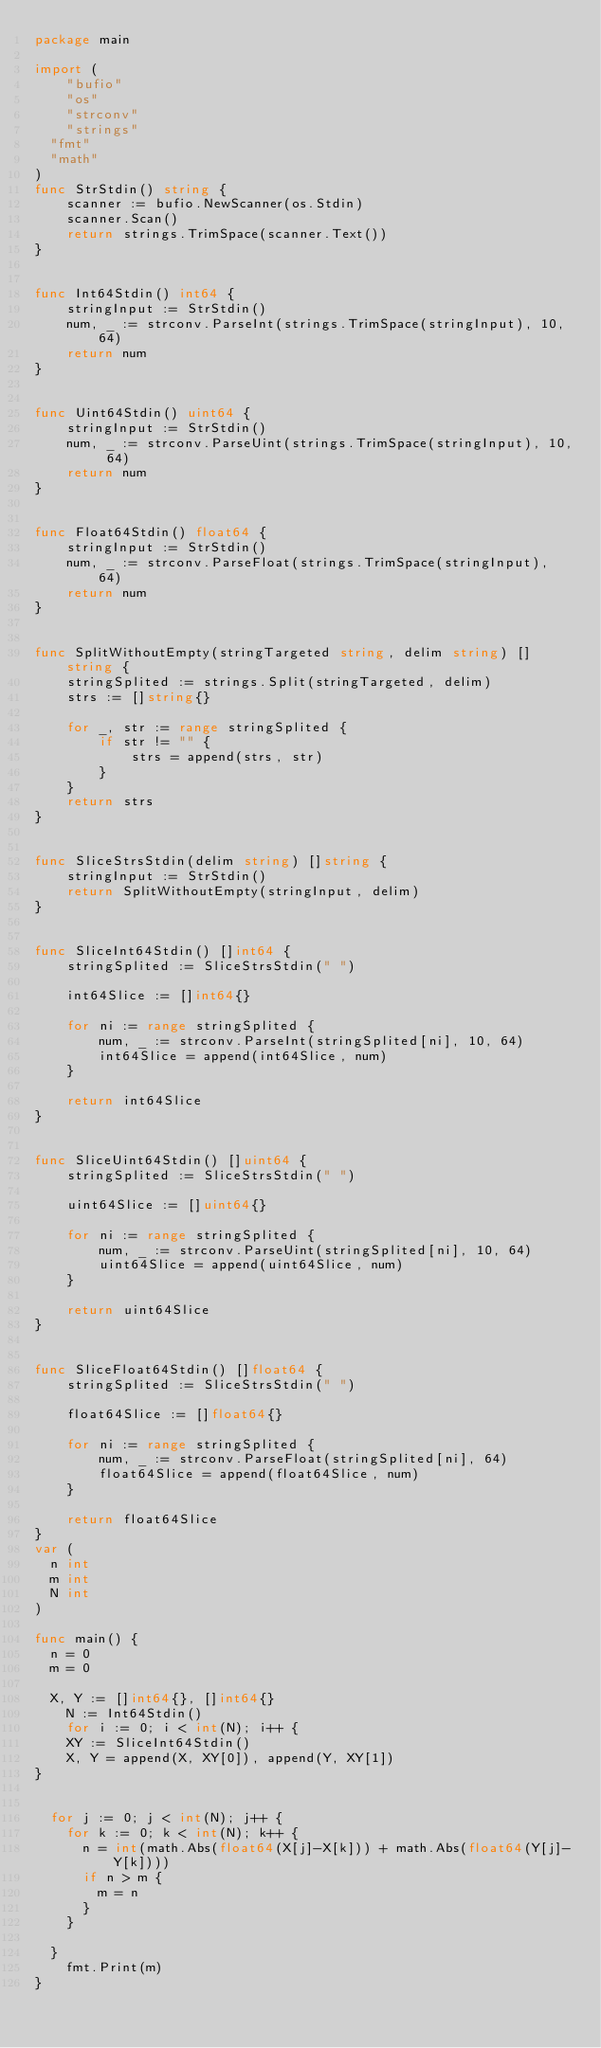<code> <loc_0><loc_0><loc_500><loc_500><_Go_>package main

import (
    "bufio"  
    "os"  
    "strconv"  
    "strings"
	"fmt"
	"math"
)
func StrStdin() string {  
    scanner := bufio.NewScanner(os.Stdin)  
    scanner.Scan()  
    return strings.TrimSpace(scanner.Text())  
}  


func Int64Stdin() int64 {  
    stringInput := StrStdin()  
    num, _ := strconv.ParseInt(strings.TrimSpace(stringInput), 10, 64)  
    return num  
}  


func Uint64Stdin() uint64 {  
    stringInput := StrStdin()  
    num, _ := strconv.ParseUint(strings.TrimSpace(stringInput), 10, 64)  
    return num  
}  


func Float64Stdin() float64 {  
    stringInput := StrStdin()  
    num, _ := strconv.ParseFloat(strings.TrimSpace(stringInput), 64)  
    return num  
}  


func SplitWithoutEmpty(stringTargeted string, delim string) []string {  
    stringSplited := strings.Split(stringTargeted, delim)  
    strs := []string{}  

    for _, str := range stringSplited {  
        if str != "" {  
            strs = append(strs, str)  
        }  
    }  
    return strs  
}  


func SliceStrsStdin(delim string) []string {  
    stringInput := StrStdin()  
    return SplitWithoutEmpty(stringInput, delim)  
}  


func SliceInt64Stdin() []int64 {  
    stringSplited := SliceStrsStdin(" ")  

    int64Slice := []int64{}  

    for ni := range stringSplited {  
        num, _ := strconv.ParseInt(stringSplited[ni], 10, 64)  
        int64Slice = append(int64Slice, num)  
    }  

    return int64Slice  
}  


func SliceUint64Stdin() []uint64 {  
    stringSplited := SliceStrsStdin(" ")  

    uint64Slice := []uint64{}  

    for ni := range stringSplited {  
        num, _ := strconv.ParseUint(stringSplited[ni], 10, 64)  
        uint64Slice = append(uint64Slice, num)  
    }  

    return uint64Slice  
}  


func SliceFloat64Stdin() []float64 {  
    stringSplited := SliceStrsStdin(" ")  

    float64Slice := []float64{}  

    for ni := range stringSplited {  
        num, _ := strconv.ParseFloat(stringSplited[ni], 64)  
        float64Slice = append(float64Slice, num)  
    }  

    return float64Slice  
}
var (
	n int
	m int
	N int
)

func main() {
	n = 0
	m = 0
	
	X, Y := []int64{}, []int64{}  
    N := Int64Stdin()  
    for i := 0; i < int(N); i++ {  
    XY := SliceInt64Stdin()   
    X, Y = append(X, XY[0]), append(Y, XY[1])  
}
	

	for j := 0; j < int(N); j++ {
		for k := 0; k < int(N); k++ {
			n = int(math.Abs(float64(X[j]-X[k])) + math.Abs(float64(Y[j]-Y[k])))
			if n > m {
				m = n
			}
		}

	}
    fmt.Print(m)
}
</code> 